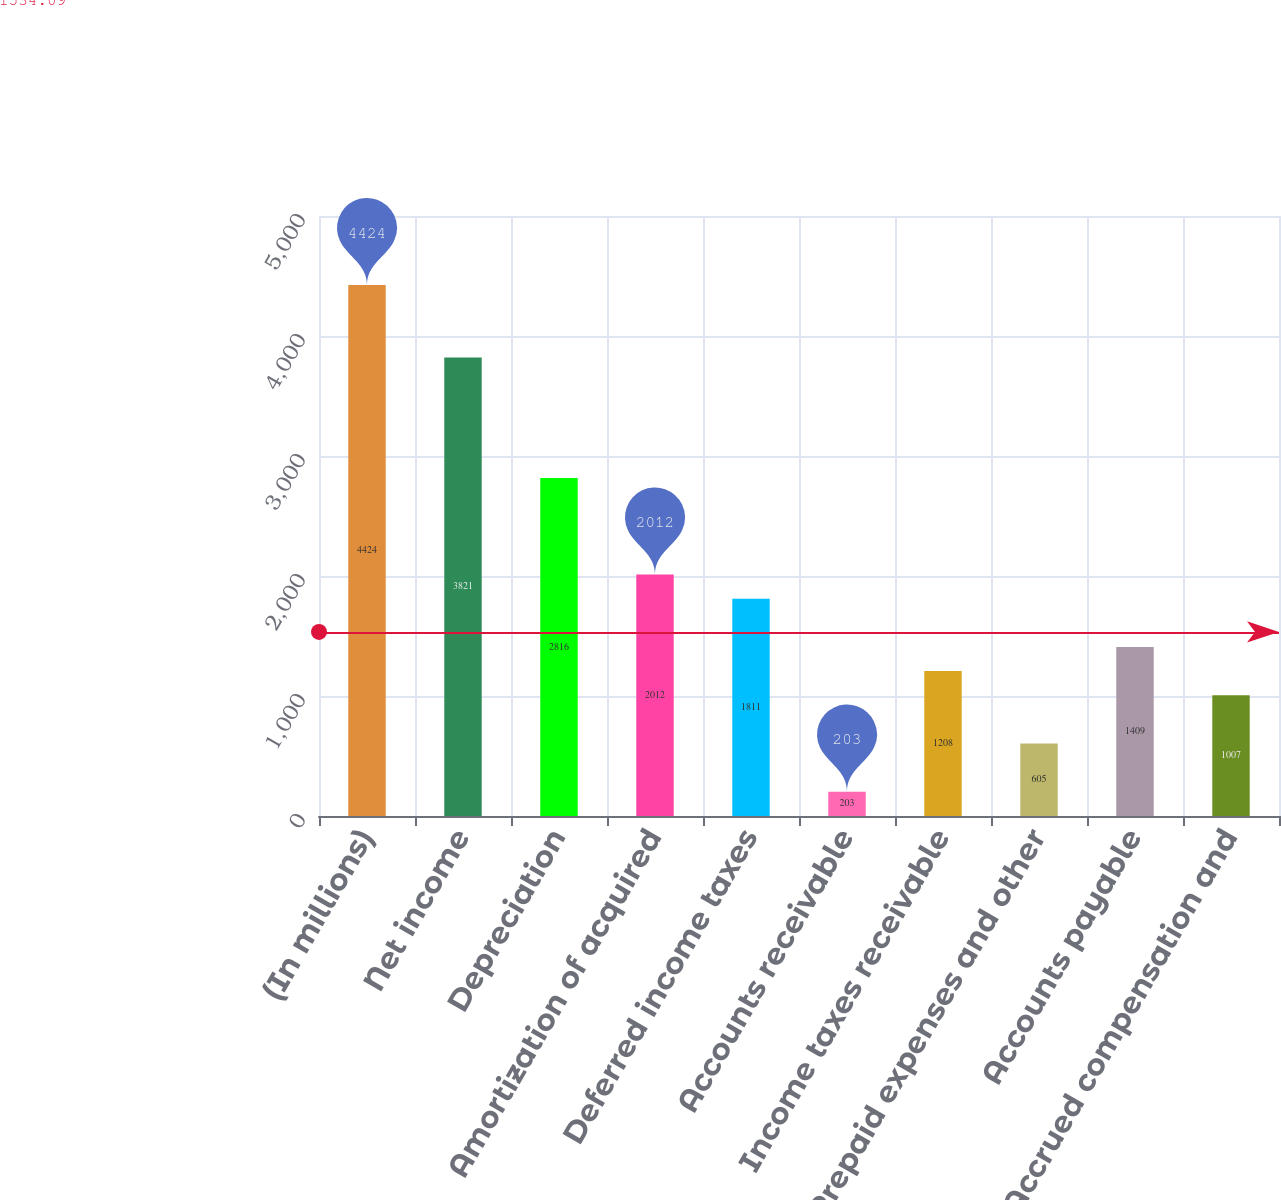Convert chart to OTSL. <chart><loc_0><loc_0><loc_500><loc_500><bar_chart><fcel>(In millions)<fcel>Net income<fcel>Depreciation<fcel>Amortization of acquired<fcel>Deferred income taxes<fcel>Accounts receivable<fcel>Income taxes receivable<fcel>Prepaid expenses and other<fcel>Accounts payable<fcel>Accrued compensation and<nl><fcel>4424<fcel>3821<fcel>2816<fcel>2012<fcel>1811<fcel>203<fcel>1208<fcel>605<fcel>1409<fcel>1007<nl></chart> 